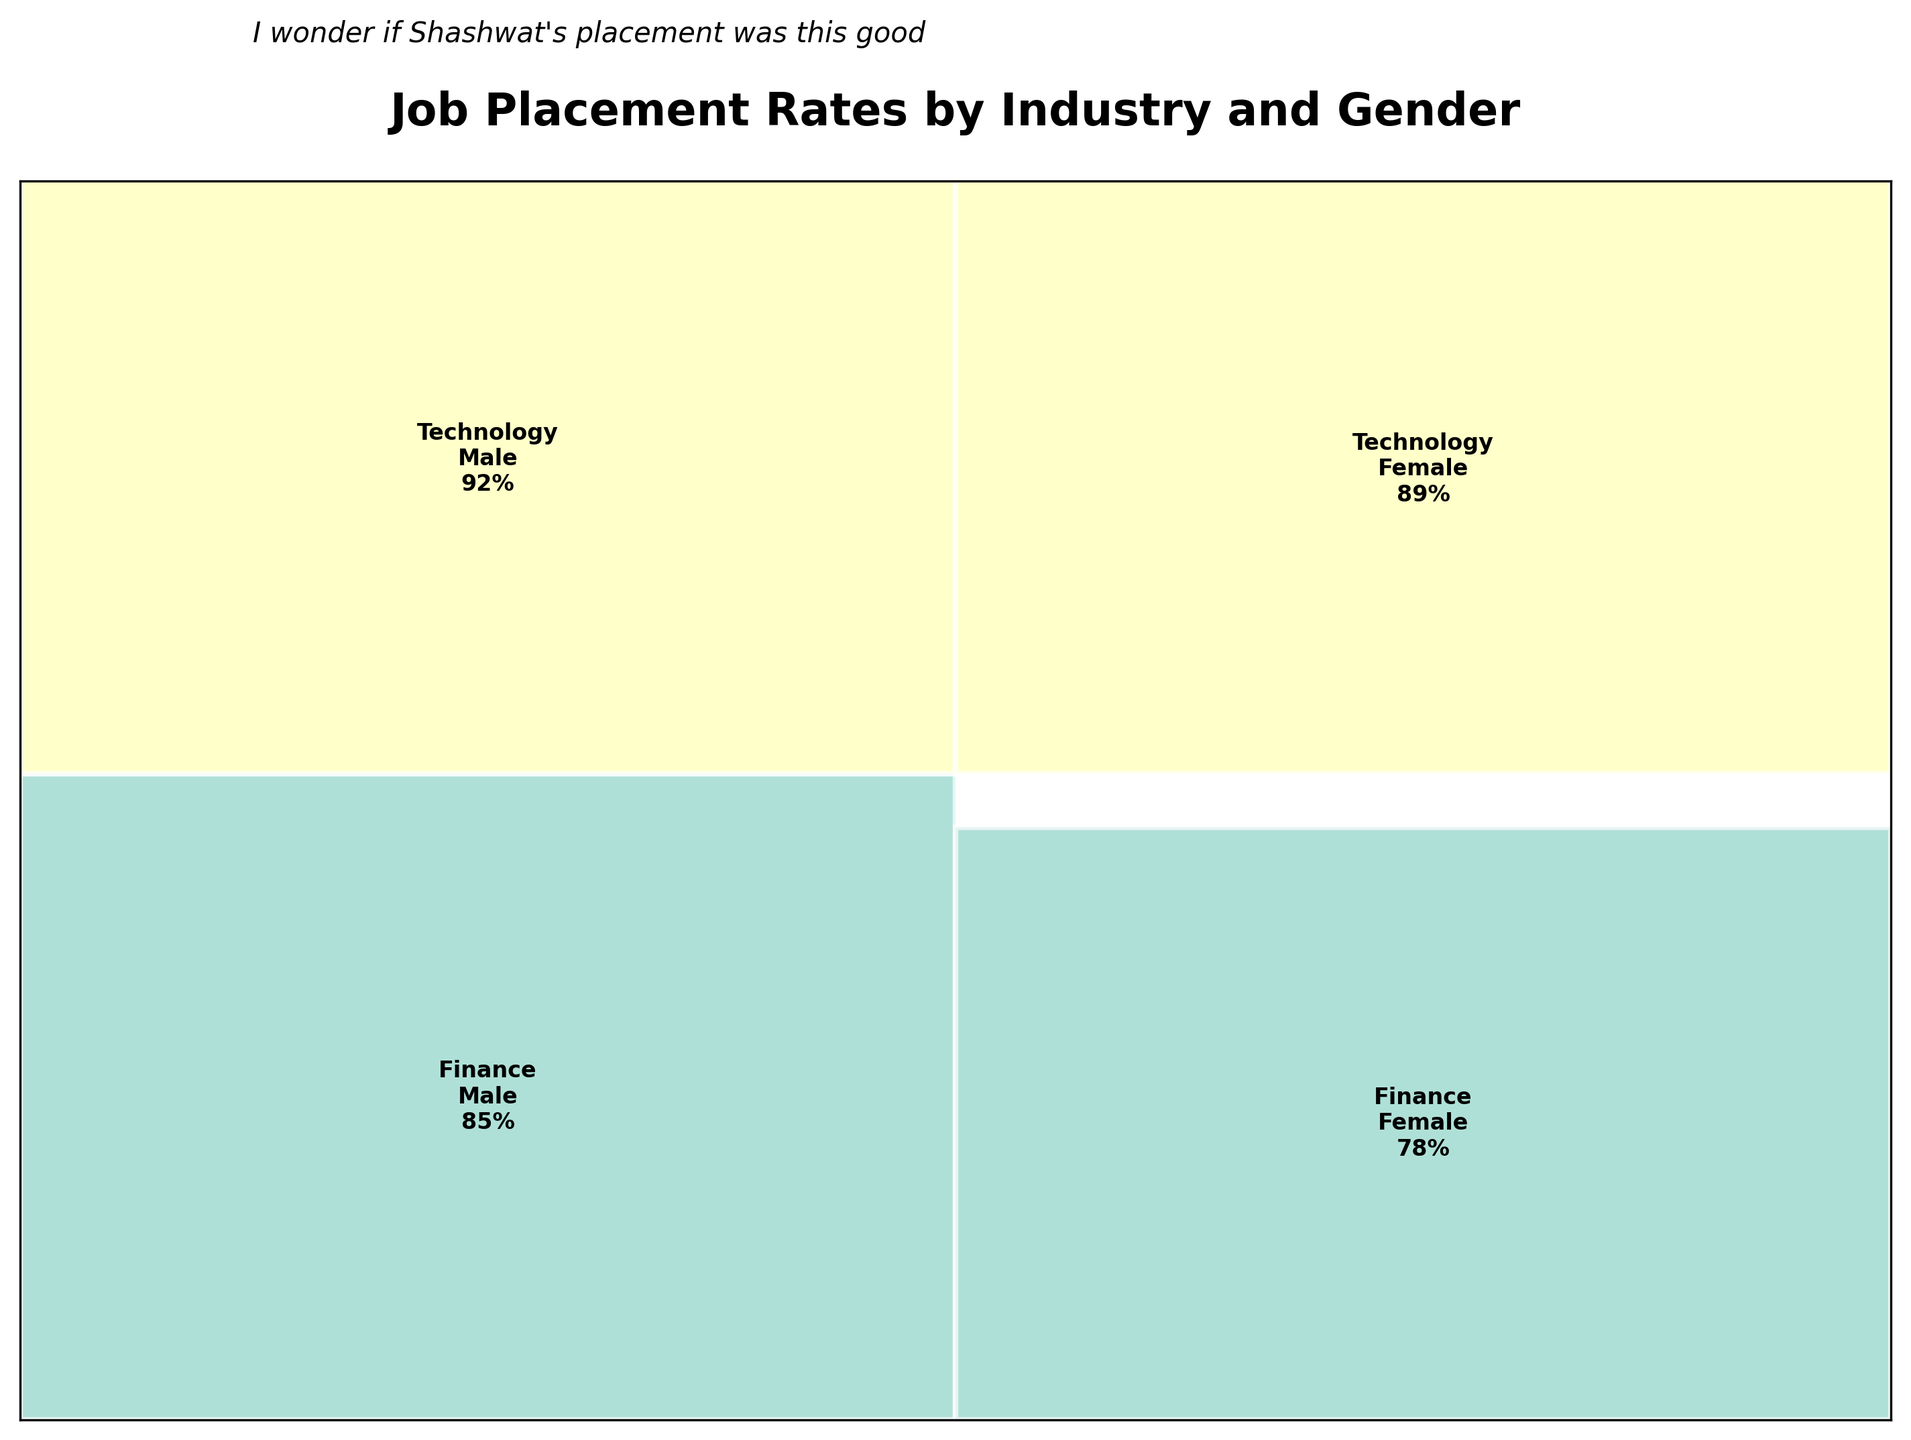what is the title of the figure? The title is usually placed at the top of the figure.
Answer: Job Placement Rates by Industry and Gender Which industry has the highest placement rate for males? Locate the rectangles labeled with different industries under the 'Male' column. The 'Technology' rectangle has the highest placement rate (92%).
Answer: Technology Which gender has better overall placement rates in the Healthcare industry? Compare the rectangles labeled 'Male' and 'Female' under the 'Healthcare' row. Females have a slightly higher placement rate (81% vs. 79%).
Answer: Female What is the range of placement rates for the Manufacturing industry? Find the 'Manufacturing' row, note the values for both gender, and calculate the difference: 76 - 72 = 4.
Answer: 4 How does the placement rate of males in Technology compare to females in Manufacturing? Compare the placement rate in 'Technology' for 'Male' (92%) with 'Manufacturing' for 'Female' (72%).
Answer: Higher Which industry exhibits the smallest gender difference in placement rates? For each industry, subtract the lower value from the higher value and find the smallest difference. 'Finance' has the smallest difference (85 - 78 = 7).
Answer: Finance What is the total placement rate for females in Hospitality and FMCG? Add the placement rates for females in 'Hospitality' (75) and 'FMCG' (80): 75 + 80 = 155.
Answer: 155 Which gender dominates the E-commerce industry in terms of placement rates? Compare the rectangles in the 'E-commerce' row for 'Male' (90%) and 'Female' (87%), males have higher rates.
Answer: Male 相比其他行业，咨询公司（Consulting）中的男性就业率如何？ 寻找“咨询公司”一行中的男性就业率（88%），并将其与其他行业进行比较。男性在咨询公司的就业率属于较高水平。
Answer: 较高 总体而言，哪个性别的就业率更高？ 比较所有行业中男女生就业率的平均数，男性整体的就业率略高一些。
Answer: 男性 